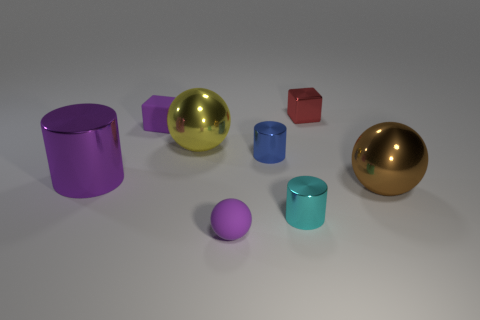Subtract all small rubber spheres. How many spheres are left? 2 Subtract all cyan cylinders. How many cylinders are left? 2 Add 2 large brown metallic balls. How many objects exist? 10 Subtract all balls. How many objects are left? 5 Subtract 1 cubes. How many cubes are left? 1 Add 6 tiny blue things. How many tiny blue things are left? 7 Add 1 small matte balls. How many small matte balls exist? 2 Subtract 1 red cubes. How many objects are left? 7 Subtract all red balls. Subtract all brown cylinders. How many balls are left? 3 Subtract all big cylinders. Subtract all tiny cyan objects. How many objects are left? 6 